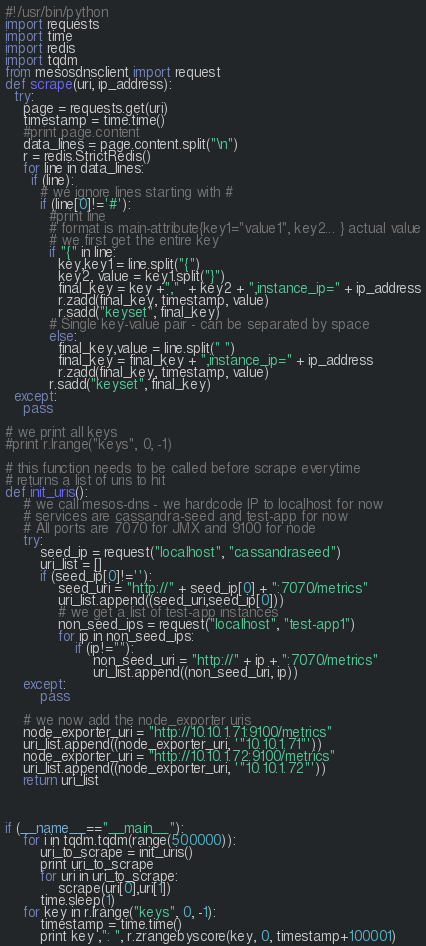<code> <loc_0><loc_0><loc_500><loc_500><_Python_>#!/usr/bin/python
import requests 
import time
import redis
import tqdm
from mesosdnsclient import request
def scrape(uri, ip_address):
  try:
    page = requests.get(uri)
    timestamp = time.time()
    #print page.content
    data_lines = page.content.split("\n")
    r = redis.StrictRedis()
    for line in data_lines:
      if (line):
        # we ignore lines starting with #
        if (line[0]!='#'):
          #print line
          # format is main-attribute{key1="value1", key2... } actual value
          # we first get the entire key
          if "{" in line: 
            key,key1 = line.split("{")
            key2, value = key1.split("}")
            final_key = key +","  + key2 + ",instance_ip=" + ip_address
            r.zadd(final_key, timestamp, value)
            r.sadd("keyset", final_key)
          # Single key-value pair - can be separated by space
          else: 
            final_key,value = line.split(" ")
            final_key = final_key + ",instance_ip=" + ip_address
            r.zadd(final_key, timestamp, value)
          r.sadd("keyset", final_key)
  except:
    pass

# we print all keys
#print r.lrange("keys", 0, -1)

# this function needs to be called before scrape everytime
# returns a list of uris to hit
def init_uris(): 
	# we call mesos-dns - we hardcode IP to localhost for now
	# services are cassandra-seed and test-app for now 
	# All ports are 7070 for JMX and 9100 for node
	try:
		seed_ip = request("localhost", "cassandraseed")
		uri_list = []
		if (seed_ip[0]!=''):
			seed_uri = "http://" + seed_ip[0] + ":7070/metrics"
			uri_list.append((seed_uri,seed_ip[0]))
			# we get a list of test-app instances
			non_seed_ips = request("localhost", "test-app1")
			for ip in non_seed_ips:
				if (ip!=""):
					non_seed_uri = "http://" + ip + ":7070/metrics"
					uri_list.append((non_seed_uri, ip))
	except:
		pass

	# we now add the node_exporter uris
	node_exporter_uri = "http://10.10.1.71:9100/metrics"
	uri_list.append((node_exporter_uri, '"10.10.1.71"'))
	node_exporter_uri = "http://10.10.1.72:9100/metrics"
	uri_list.append((node_exporter_uri, '"10.10.1.72"'))
	return uri_list
	


if (__name__=="__main__"):
	for i in tqdm.tqdm(range(500000)):
		uri_to_scrape = init_uris()
		print uri_to_scrape
		for uri in uri_to_scrape:
			scrape(uri[0],uri[1])
		time.sleep(1)
	for key in r.lrange("keys", 0, -1):
		timestamp = time.time()
		print key ,": ", r.zrangebyscore(key, 0, timestamp+100001)


</code> 